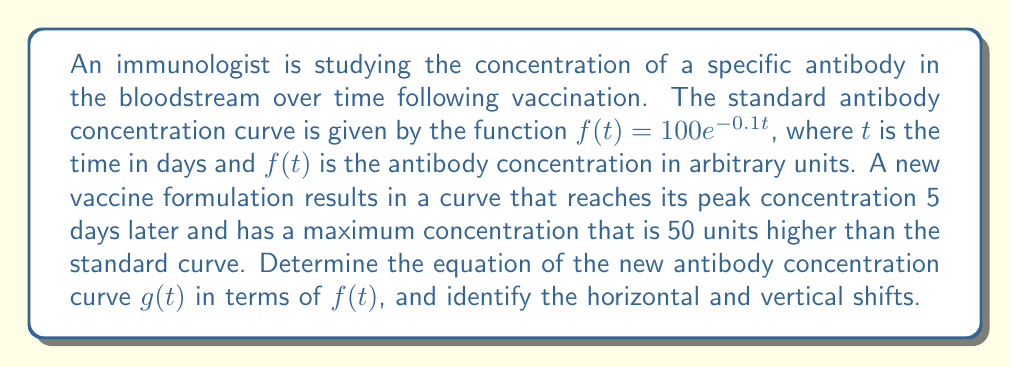Can you solve this math problem? To solve this problem, we need to apply horizontal and vertical transformations to the original function $f(t)$. Let's break it down step by step:

1. Horizontal shift:
   The new curve reaches its peak 5 days later, which means we need to shift the function 5 units to the right. This is achieved by replacing $t$ with $(t-5)$ in the original function.

2. Vertical shift:
   The maximum concentration is 50 units higher than the standard curve. This means we need to shift the function 50 units up. This is done by adding 50 to the function.

3. Combining the transformations:
   The new function $g(t)$ can be expressed in terms of $f(t)$ as follows:
   $g(t) = f(t-5) + 50$

4. Identifying the shifts:
   - Horizontal shift: 5 units to the right
   - Vertical shift: 50 units up

To verify this, we can substitute the original function:
$g(t) = 100e^{-0.1(t-5)} + 50$

This equation represents the new antibody concentration curve that peaks 5 days later and has a maximum concentration 50 units higher than the standard curve.
Answer: $g(t) = f(t-5) + 50$
Horizontal shift: 5 units right
Vertical shift: 50 units up 